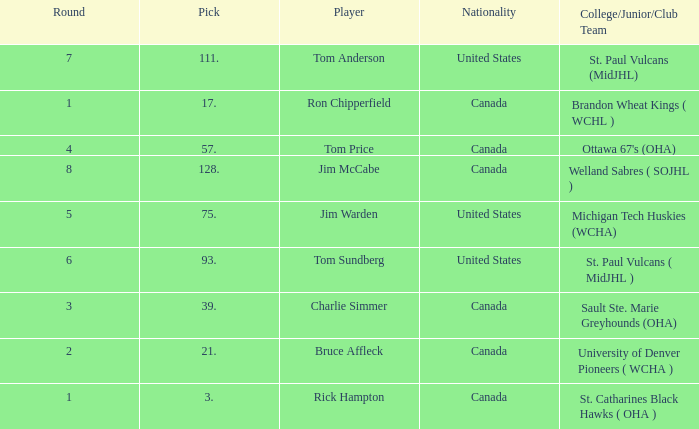Can you tell me the Nationality that has the Round smaller than 5, and the Player of bruce affleck? Canada. 